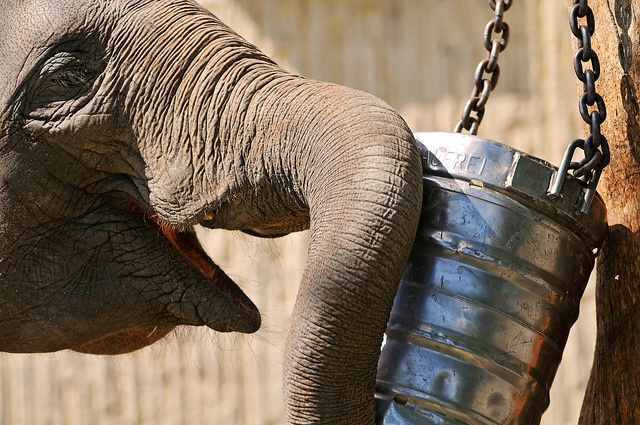Describe the objects in this image and their specific colors. I can see a elephant in gray, black, tan, maroon, and darkgray tones in this image. 